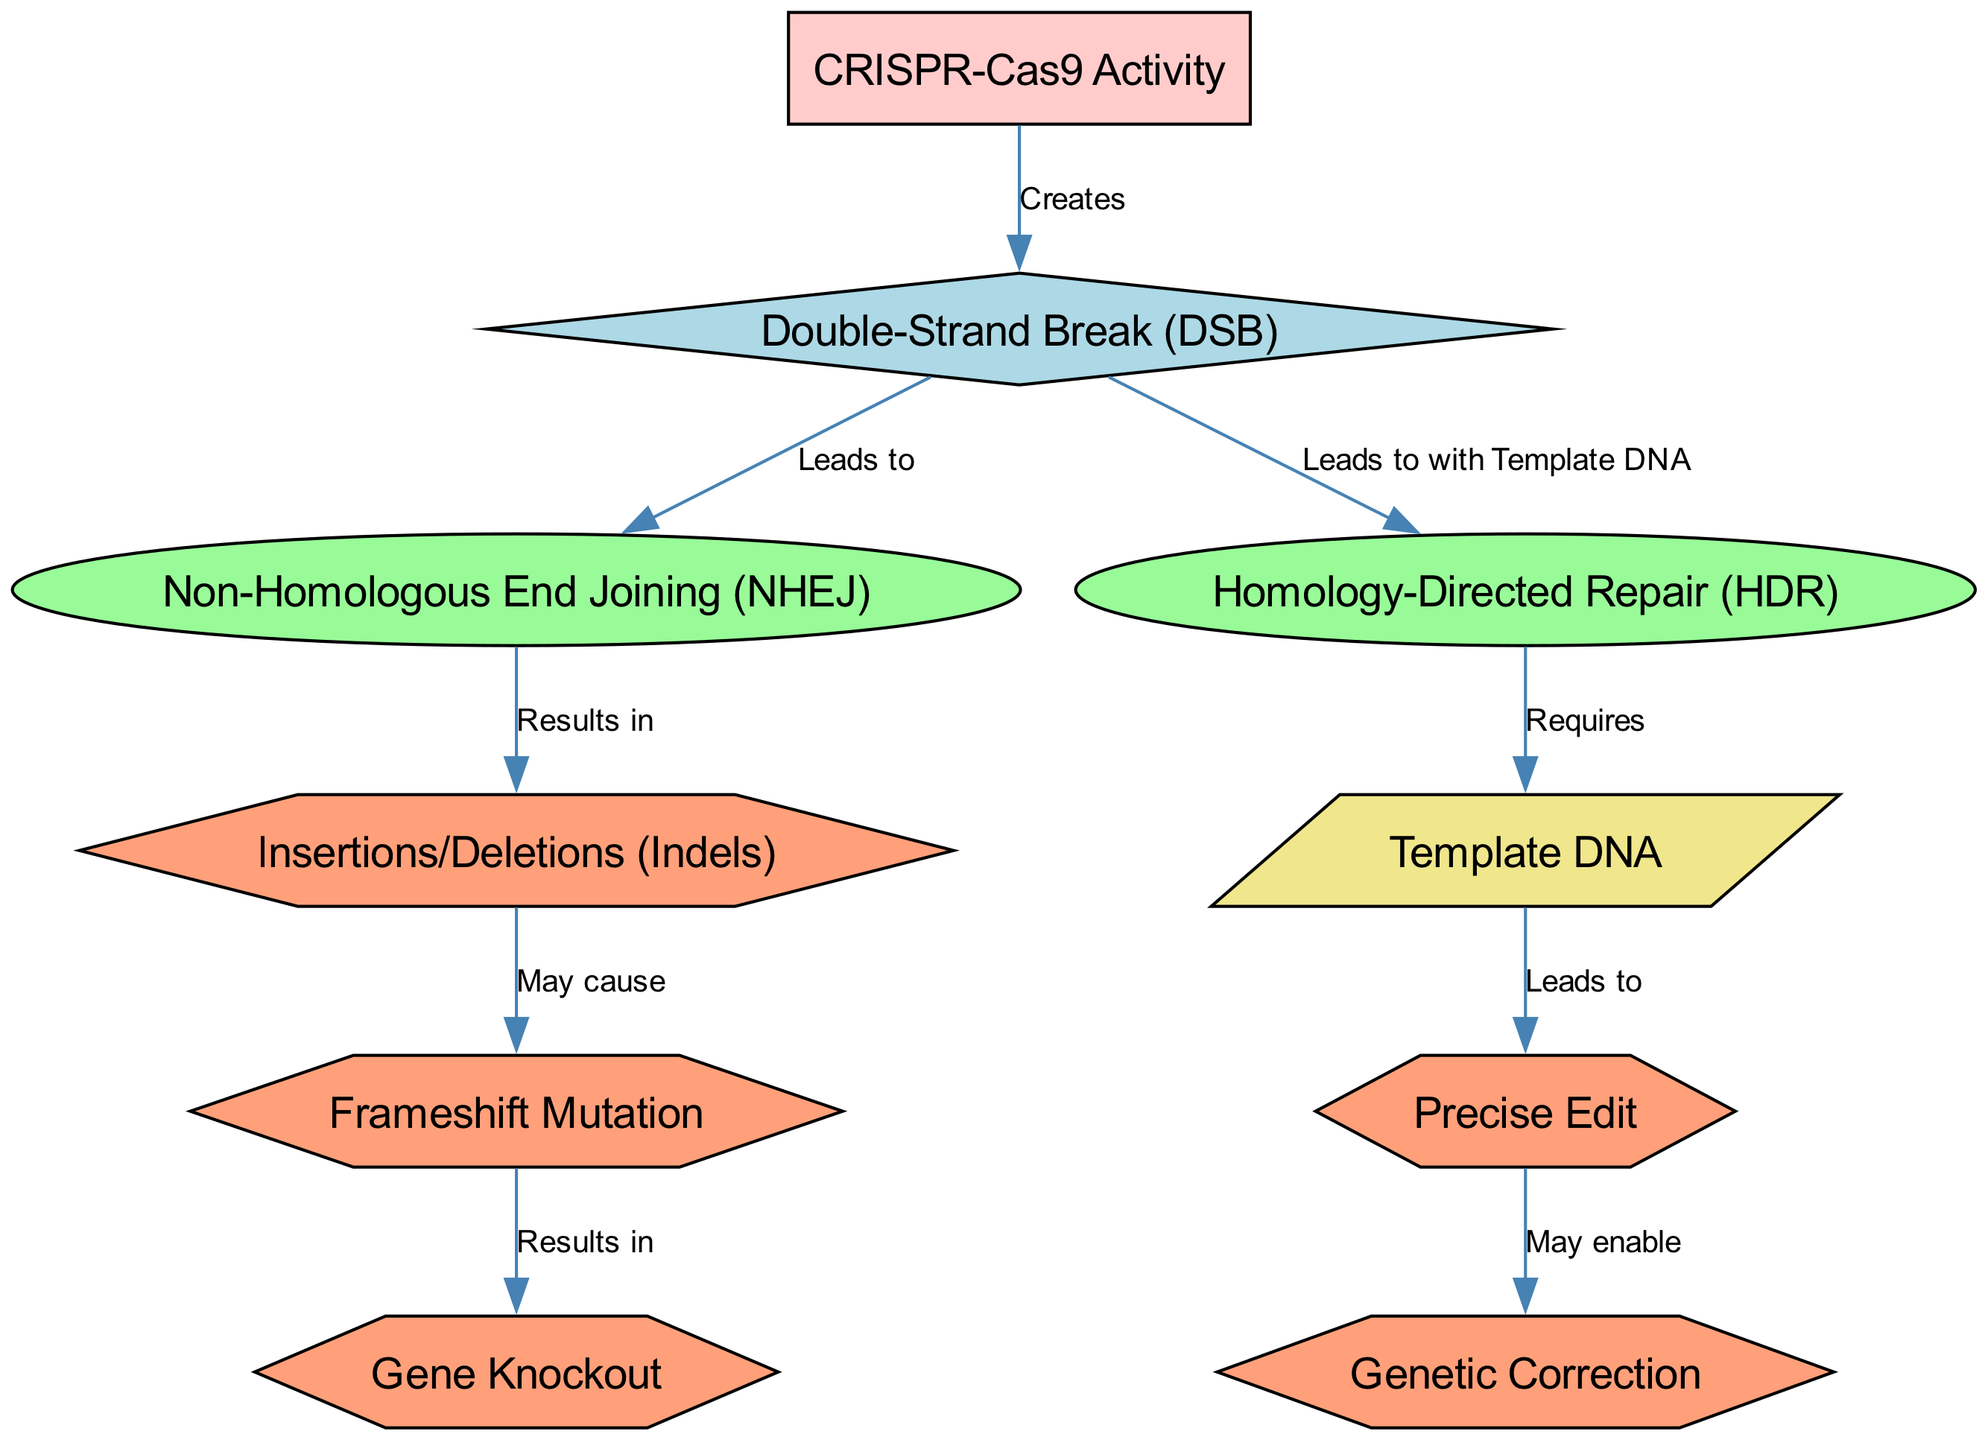What event does CRISPR-Cas9 Activity create? The diagram shows that the CRISPR-Cas9 Activity leads to the creation of a Double-Strand Break (DSB), as indicated by an arrow labeled "Creates" connecting these two nodes.
Answer: Double-Strand Break (DSB) Which repair pathway is associated with Non-Homologous End Joining? In the diagram, Non-Homologous End Joining (NHEJ) results from the Double-Strand Break (DSB), as indicated by an arrow labeled "Leads to."
Answer: NHEJ What does Homology-Directed Repair require? The diagram specifies that the Homology-Directed Repair (HDR) pathway requires Template DNA, as shown by the arrow connecting these two nodes labeled "Requires."
Answer: Template DNA What outcomes can result from Non-Homologous End Joining? According to the diagram, Non-Homologous End Joining (NHEJ) results in Insertions/Deletions (Indels), which can subsequently lead to Frameshift Mutation and Gene Knockout.
Answer: Indels What may enable genetic correction according to the diagram? The diagram illustrates that a Precise Edit can enable Genetic Correction, as represented by the arrow labeled "May enable" connecting these two outcomes. To achieve a Precise Edit, one must first follow the Homology-Directed Repair pathway using Template DNA.
Answer: Precise Edit What is the relationship between Insertions/Deletions and Frameshift Mutation? The diagram indicates that Insertions/Deletions (Indels) may cause Frameshift Mutation, with a connecting arrow labeled "May cause" linking the two nodes. This implies a potential causal relationship.
Answer: May cause How many pathways are illustrated in the diagram? The diagram features two pathways: Non-Homologous End Joining (NHEJ) and Homology-Directed Repair (HDR), both connected by the Double-Strand Break event.
Answer: Two Which outcome follows from Homology-Directed Repair? The diagram shows that Homology-Directed Repair (HDR) leads to a Precise Edit, as indicated by the connecting arrow labeled "Leads to." This describes the end result of the HDR pathway.
Answer: Precise Edit What mutation can result from a Frameshift Mutation? The diagram indicates that a Frameshift Mutation can result in a Gene Knockout, as represented by the arrow labeled "Results in." This signifies the potential consequence of Frameshift Mutation within the NHEJ pathway.
Answer: Gene Knockout 